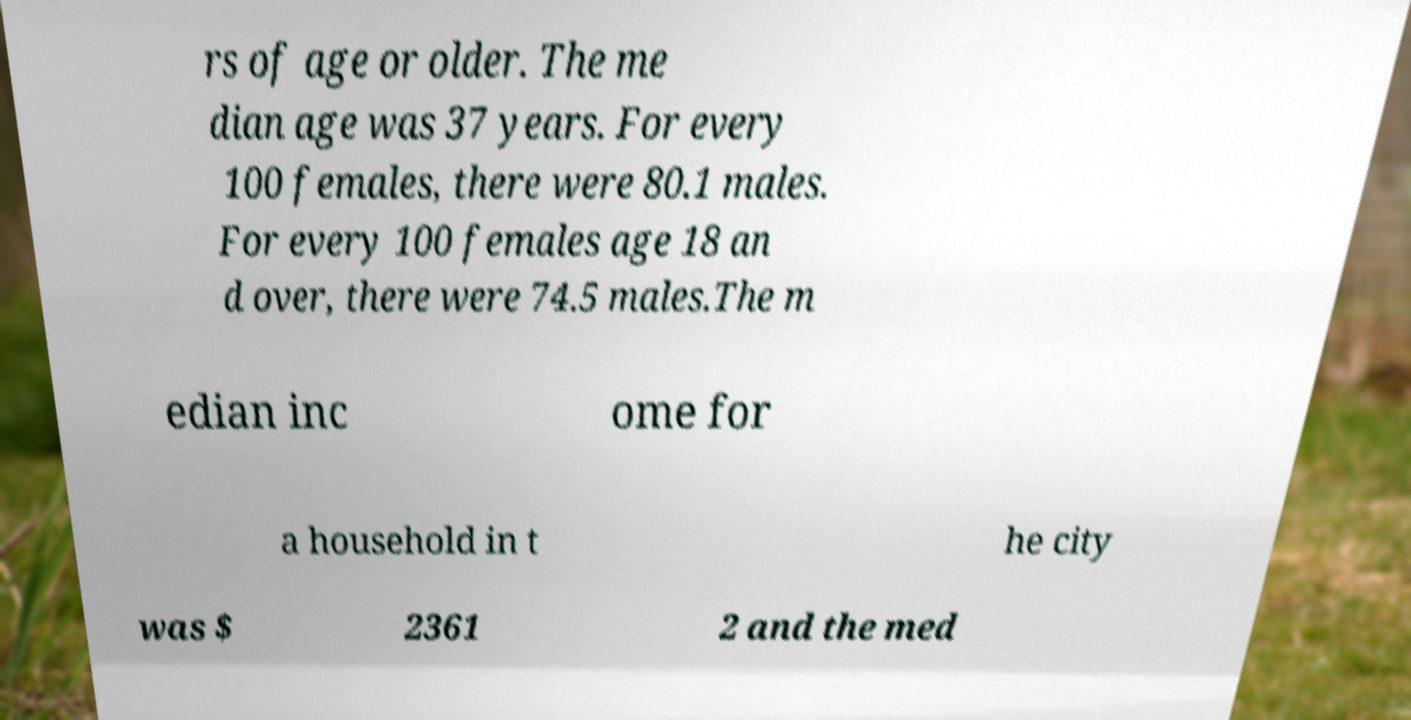I need the written content from this picture converted into text. Can you do that? rs of age or older. The me dian age was 37 years. For every 100 females, there were 80.1 males. For every 100 females age 18 an d over, there were 74.5 males.The m edian inc ome for a household in t he city was $ 2361 2 and the med 